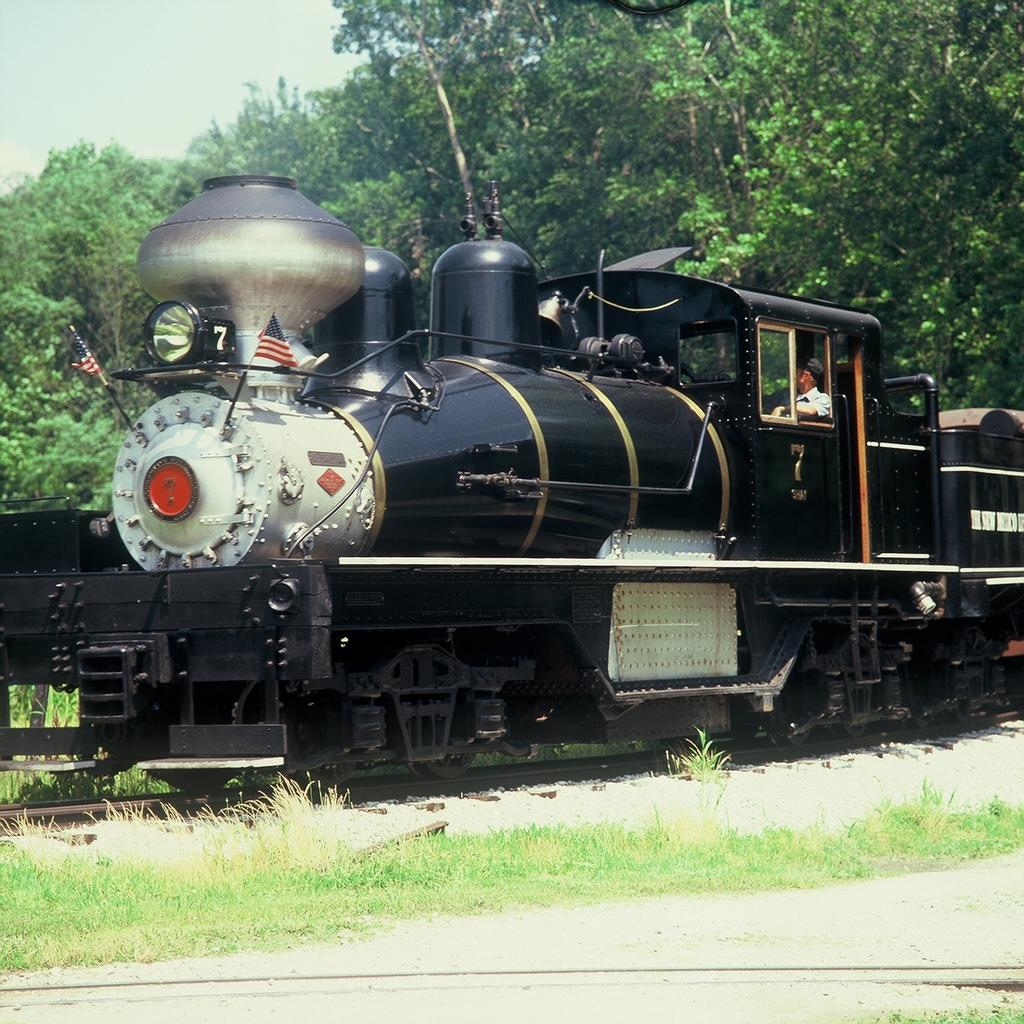What type of vehicle is in the image? There is a steam engine in the image. Where is the steam engine located? The steam engine is placed on a track. Who is inside the steam engine? There is a person sitting inside the engine cabin. What is the person wearing? The person is wearing a cap. What can be seen in the background of the image? Trees and the sky are visible in the background of the image. How many children are playing with the sun in the image? There are no children or sun present in the image; it features a steam engine on a track with a person inside the cabin. What type of rail is used for the steam engine in the image? There is no specific type of rail mentioned in the image, only that the steam engine is placed on a track. 